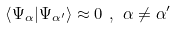<formula> <loc_0><loc_0><loc_500><loc_500>\left \langle \Psi _ { \alpha } | \Psi _ { \alpha ^ { \prime } } \right \rangle \approx 0 \ , \ \alpha \not = \alpha ^ { \prime }</formula> 